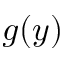Convert formula to latex. <formula><loc_0><loc_0><loc_500><loc_500>g ( y )</formula> 